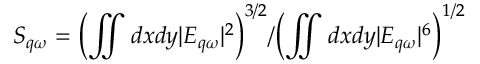<formula> <loc_0><loc_0><loc_500><loc_500>S _ { q \omega } = { \left ( \iint d x d y | E _ { q \omega } | ^ { 2 } \right ) ^ { 3 / 2 } } / { \left ( \iint d x d y | E _ { q \omega } | ^ { 6 } \right ) ^ { 1 / 2 } }</formula> 